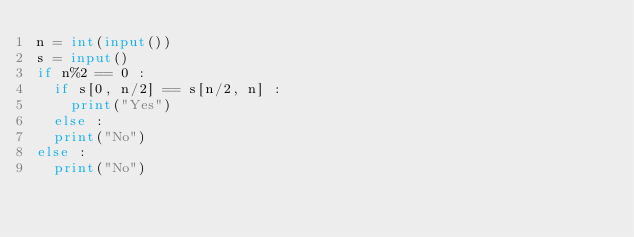<code> <loc_0><loc_0><loc_500><loc_500><_Python_>n = int(input())
s = input()
if n%2 == 0 :
  if s[0, n/2] == s[n/2, n] :
    print("Yes")
  else :
	print("No")
else :
  print("No")</code> 